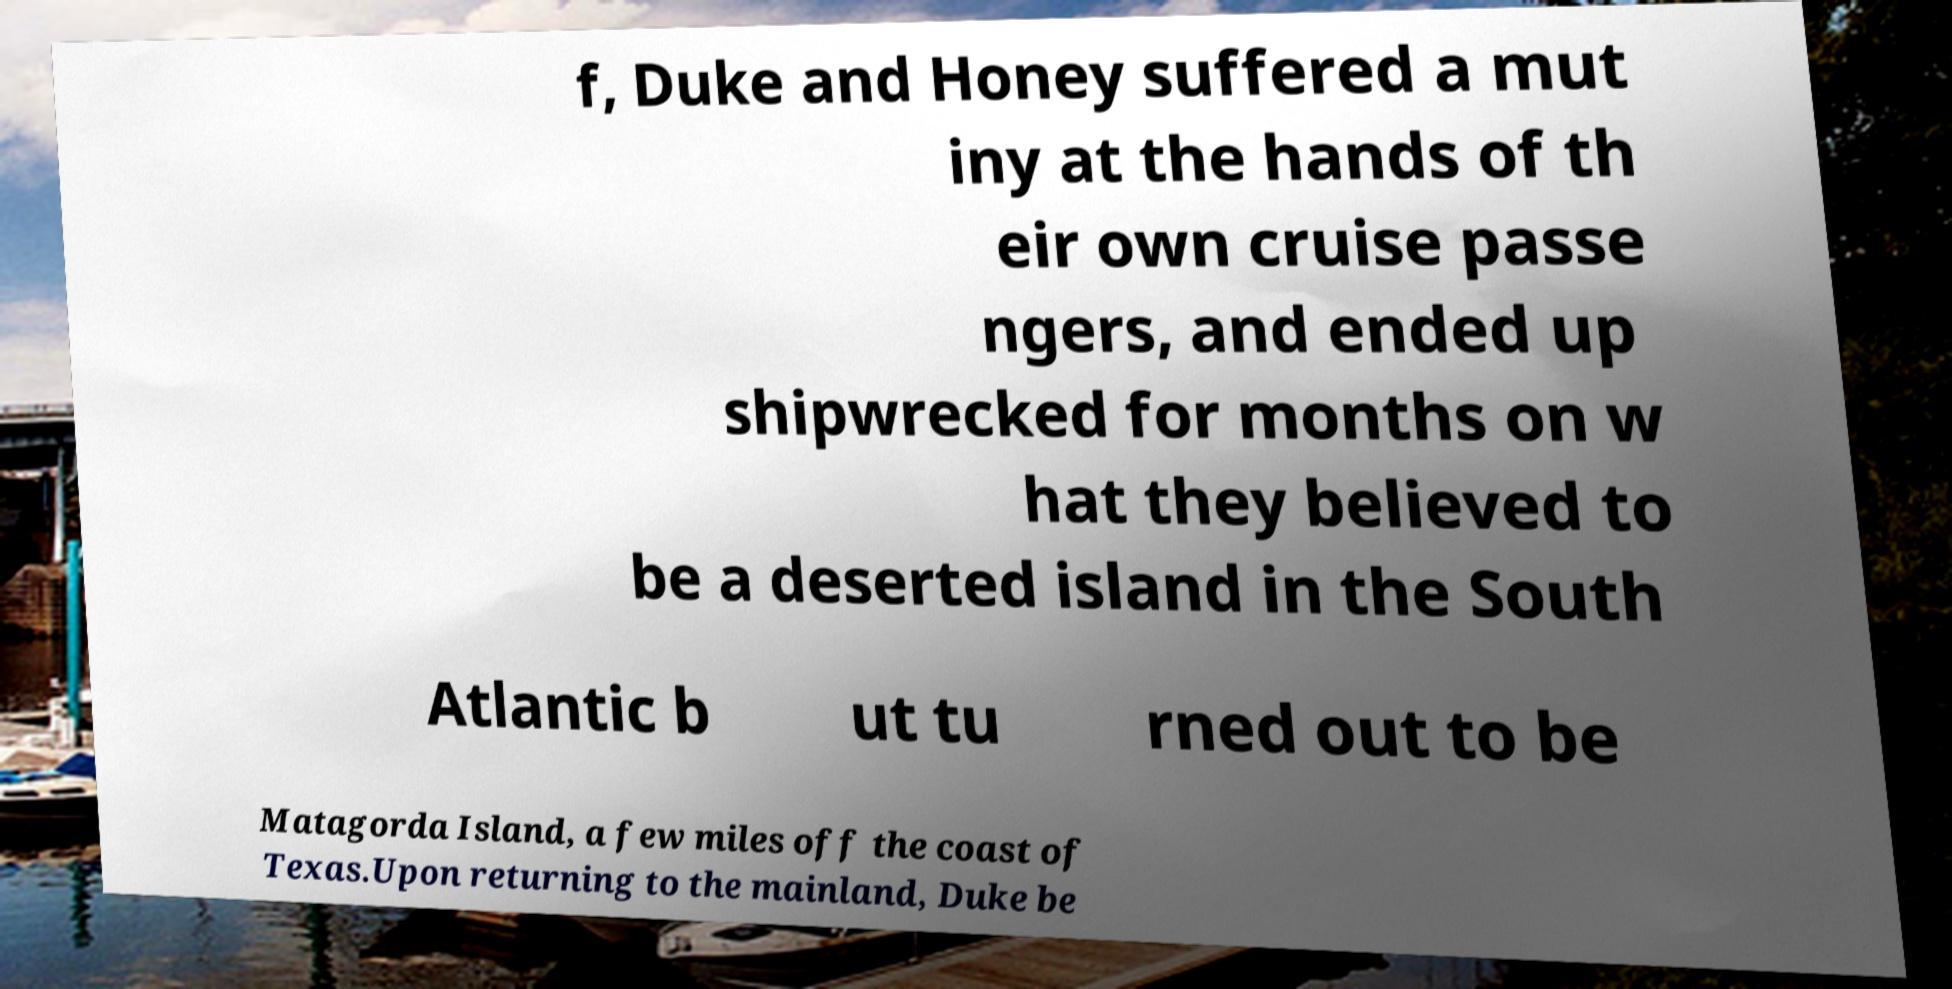Can you accurately transcribe the text from the provided image for me? f, Duke and Honey suffered a mut iny at the hands of th eir own cruise passe ngers, and ended up shipwrecked for months on w hat they believed to be a deserted island in the South Atlantic b ut tu rned out to be Matagorda Island, a few miles off the coast of Texas.Upon returning to the mainland, Duke be 